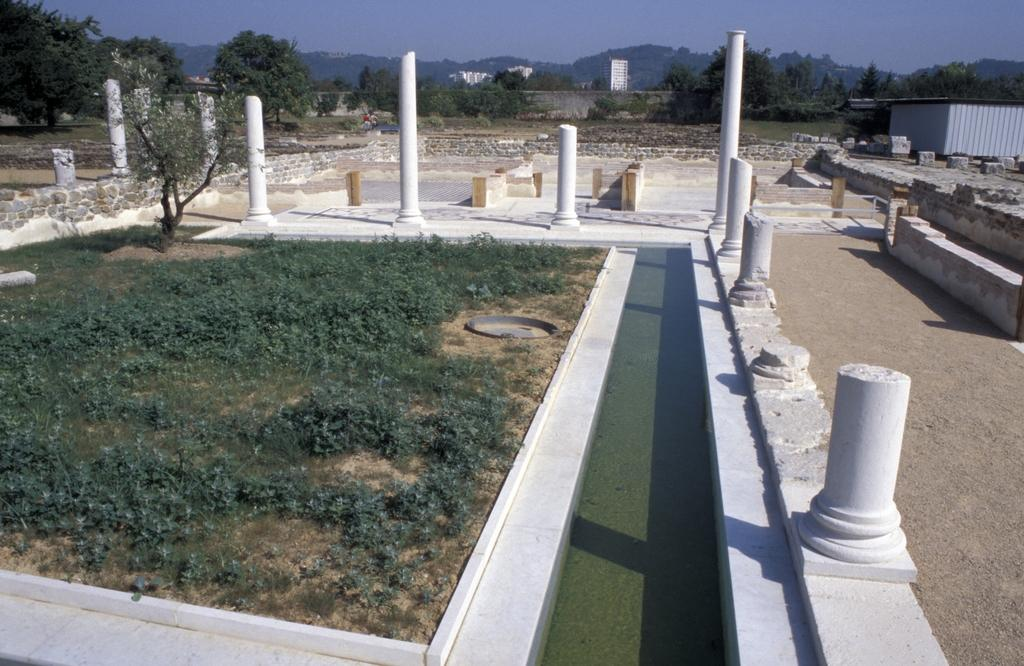What architectural features can be seen in the image? There are pillars and a wall visible in the image. What natural elements are present in the image? There is water, grass, trees, and a hill visible in the image. What man-made structures can be seen in the image? There is a shed and buildings visible in the image. What part of the natural environment is visible in the image? The sky is visible in the image. What type of quince is being used to light the flame in the image? There is no quince or flame present in the image. How does the afterthought affect the hill in the image? There is no afterthought mentioned in the image, and the hill is not affected by any such concept. 